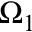<formula> <loc_0><loc_0><loc_500><loc_500>\Omega _ { 1 }</formula> 